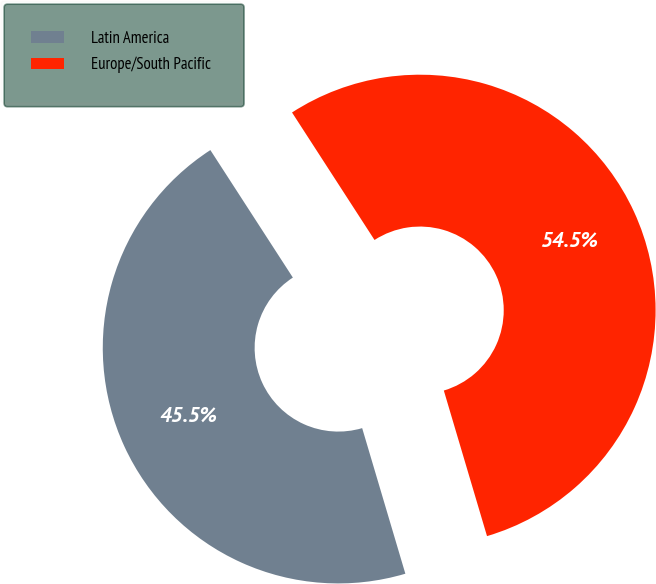<chart> <loc_0><loc_0><loc_500><loc_500><pie_chart><fcel>Latin America<fcel>Europe/South Pacific<nl><fcel>45.45%<fcel>54.55%<nl></chart> 